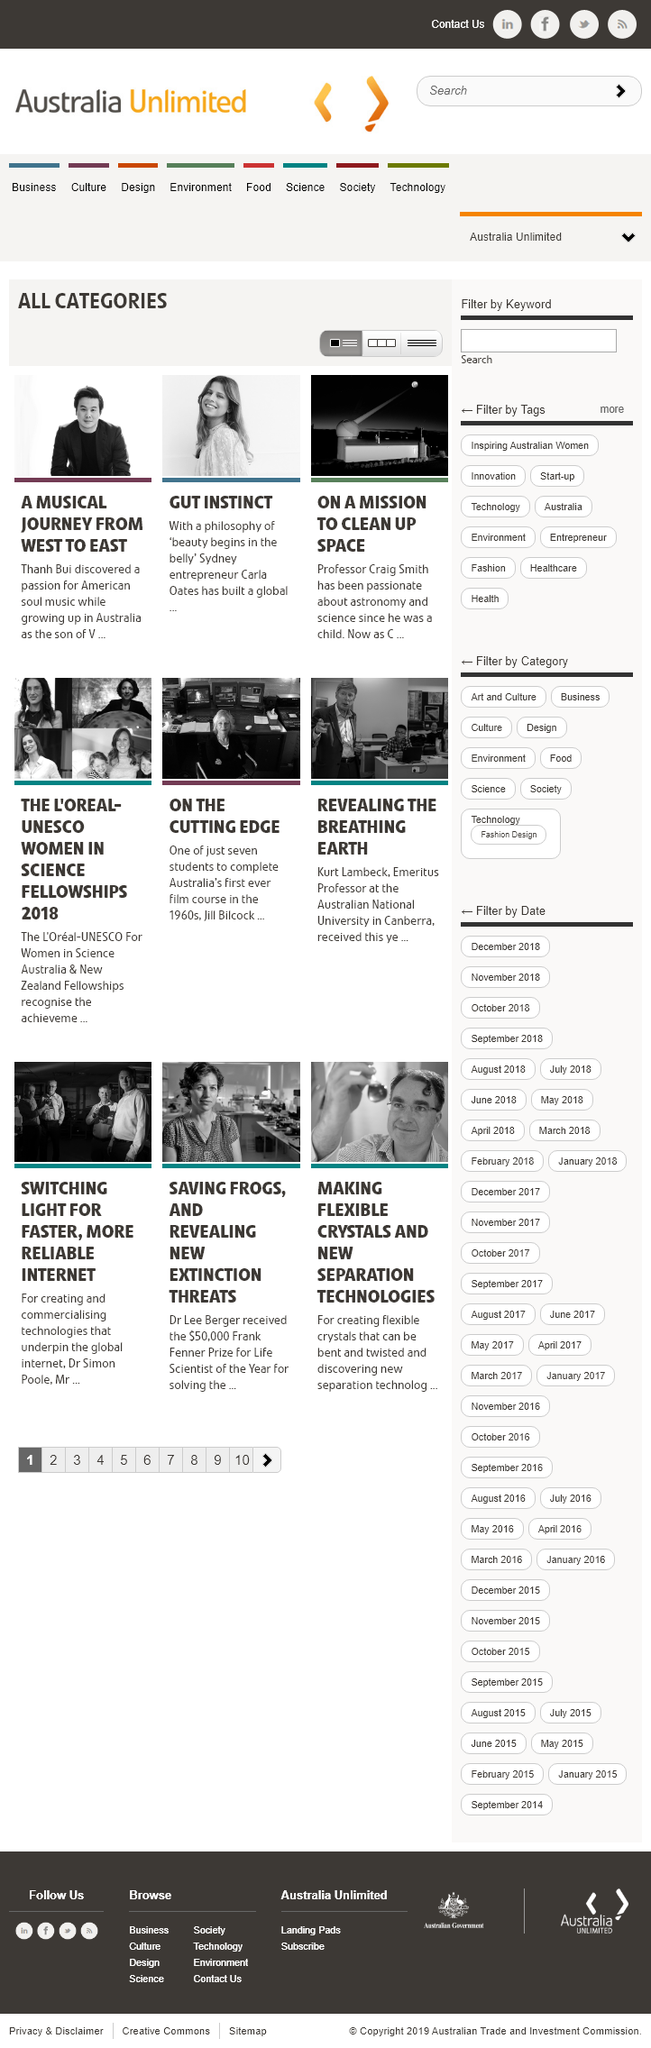Highlight a few significant elements in this photo. Professor Craig Smith is on a mission to clean up space. Thanh Bui was on a musical journey. Carla Oates is originally from Sydney. 